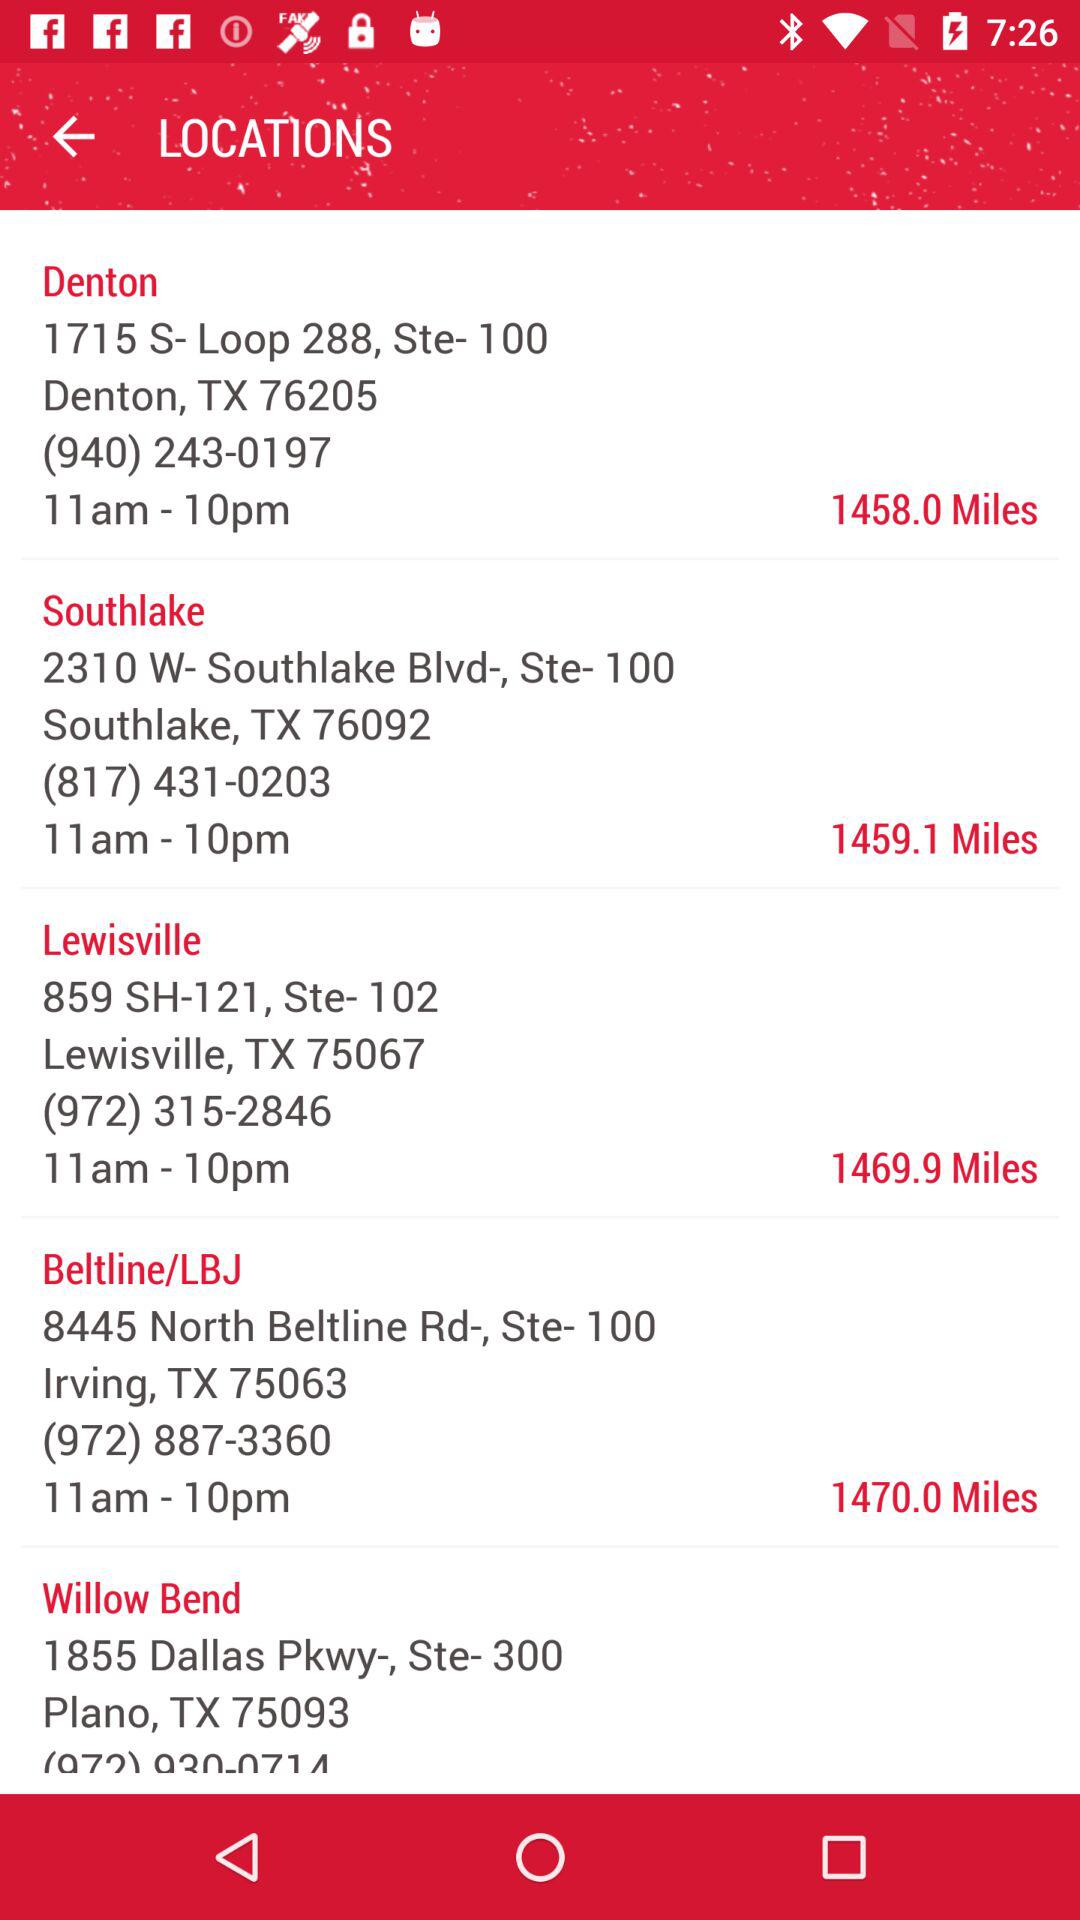When does the Lewisville location open? The Lewisville location opens at 11 a.m. 